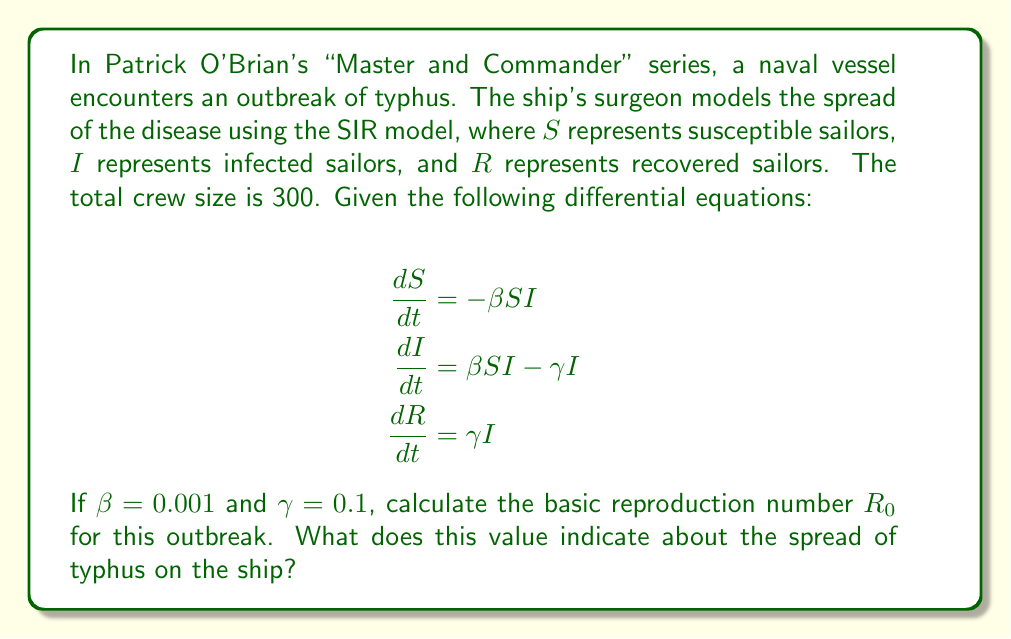Provide a solution to this math problem. To solve this problem, we'll follow these steps:

1) The basic reproduction number $R_0$ is defined as the average number of secondary infections caused by one infected individual in a completely susceptible population.

2) For the SIR model, $R_0$ is given by the formula:

   $$R_0 = \frac{\beta N}{\gamma}$$

   Where:
   - $\beta$ is the transmission rate
   - $N$ is the total population
   - $\gamma$ is the recovery rate

3) We're given:
   - $\beta = 0.001$
   - $\gamma = 0.1$
   - $N = 300$ (total crew size)

4) Let's substitute these values into the formula:

   $$R_0 = \frac{0.001 \times 300}{0.1}$$

5) Simplify:
   
   $$R_0 = \frac{0.3}{0.1} = 3$$

6) Interpretation: 
   - If $R_0 > 1$, the disease will spread exponentially.
   - If $R_0 < 1$, the disease will die out.
   - If $R_0 = 1$, the disease will become endemic.

   In this case, $R_0 = 3$, which is greater than 1.
Answer: $R_0 = 3$. This indicates the typhus outbreak will spread exponentially on the ship. 